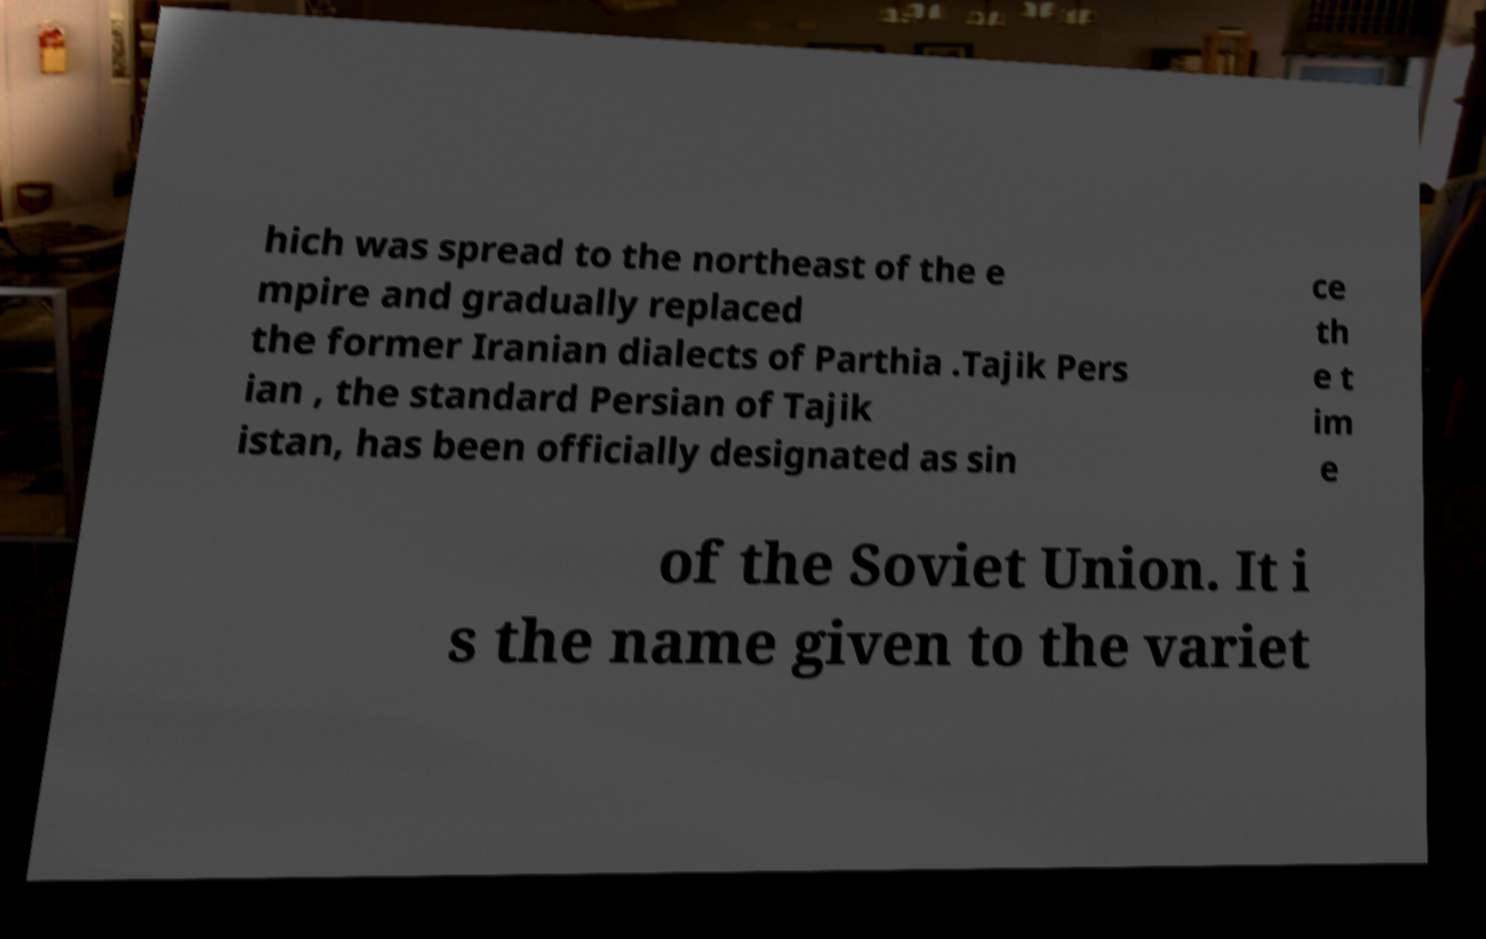I need the written content from this picture converted into text. Can you do that? hich was spread to the northeast of the e mpire and gradually replaced the former Iranian dialects of Parthia .Tajik Pers ian , the standard Persian of Tajik istan, has been officially designated as sin ce th e t im e of the Soviet Union. It i s the name given to the variet 